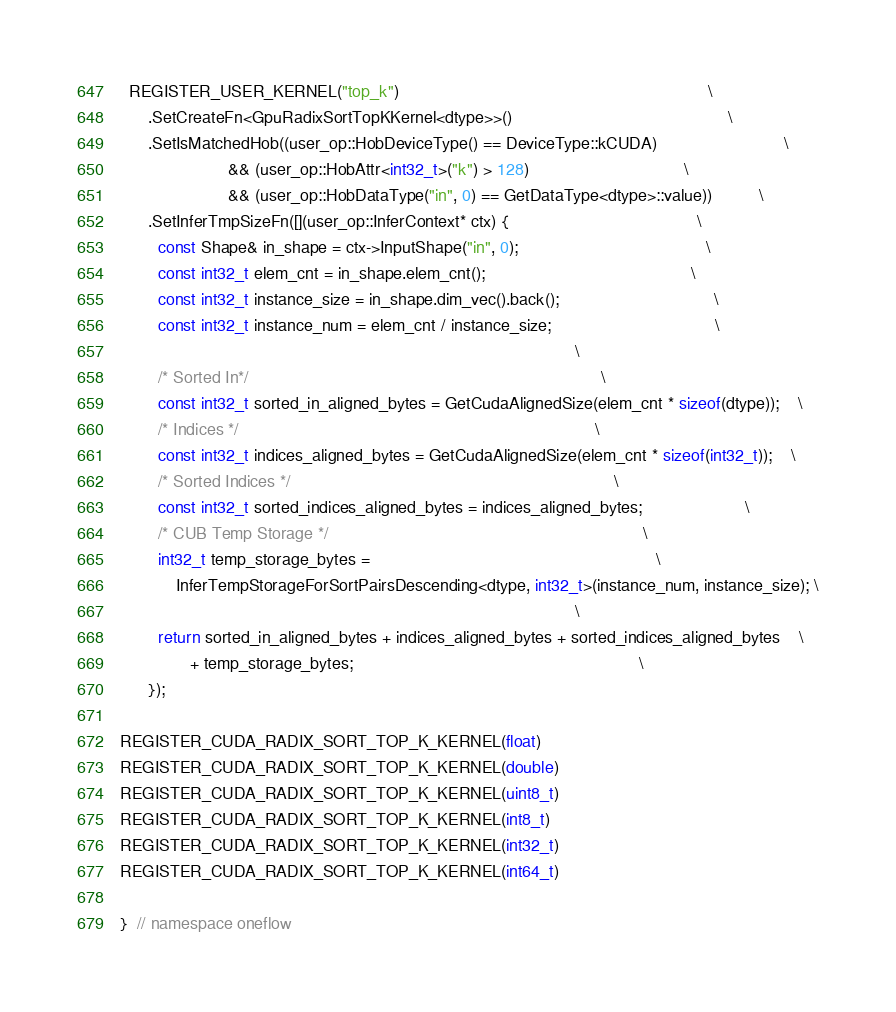<code> <loc_0><loc_0><loc_500><loc_500><_Cuda_>  REGISTER_USER_KERNEL("top_k")                                                                  \
      .SetCreateFn<GpuRadixSortTopKKernel<dtype>>()                                              \
      .SetIsMatchedHob((user_op::HobDeviceType() == DeviceType::kCUDA)                           \
                       && (user_op::HobAttr<int32_t>("k") > 128)                                 \
                       && (user_op::HobDataType("in", 0) == GetDataType<dtype>::value))          \
      .SetInferTmpSizeFn([](user_op::InferContext* ctx) {                                        \
        const Shape& in_shape = ctx->InputShape("in", 0);                                        \
        const int32_t elem_cnt = in_shape.elem_cnt();                                            \
        const int32_t instance_size = in_shape.dim_vec().back();                                 \
        const int32_t instance_num = elem_cnt / instance_size;                                   \
                                                                                                 \
        /* Sorted In*/                                                                           \
        const int32_t sorted_in_aligned_bytes = GetCudaAlignedSize(elem_cnt * sizeof(dtype));    \
        /* Indices */                                                                            \
        const int32_t indices_aligned_bytes = GetCudaAlignedSize(elem_cnt * sizeof(int32_t));    \
        /* Sorted Indices */                                                                     \
        const int32_t sorted_indices_aligned_bytes = indices_aligned_bytes;                      \
        /* CUB Temp Storage */                                                                   \
        int32_t temp_storage_bytes =                                                             \
            InferTempStorageForSortPairsDescending<dtype, int32_t>(instance_num, instance_size); \
                                                                                                 \
        return sorted_in_aligned_bytes + indices_aligned_bytes + sorted_indices_aligned_bytes    \
               + temp_storage_bytes;                                                             \
      });

REGISTER_CUDA_RADIX_SORT_TOP_K_KERNEL(float)
REGISTER_CUDA_RADIX_SORT_TOP_K_KERNEL(double)
REGISTER_CUDA_RADIX_SORT_TOP_K_KERNEL(uint8_t)
REGISTER_CUDA_RADIX_SORT_TOP_K_KERNEL(int8_t)
REGISTER_CUDA_RADIX_SORT_TOP_K_KERNEL(int32_t)
REGISTER_CUDA_RADIX_SORT_TOP_K_KERNEL(int64_t)

}  // namespace oneflow
</code> 